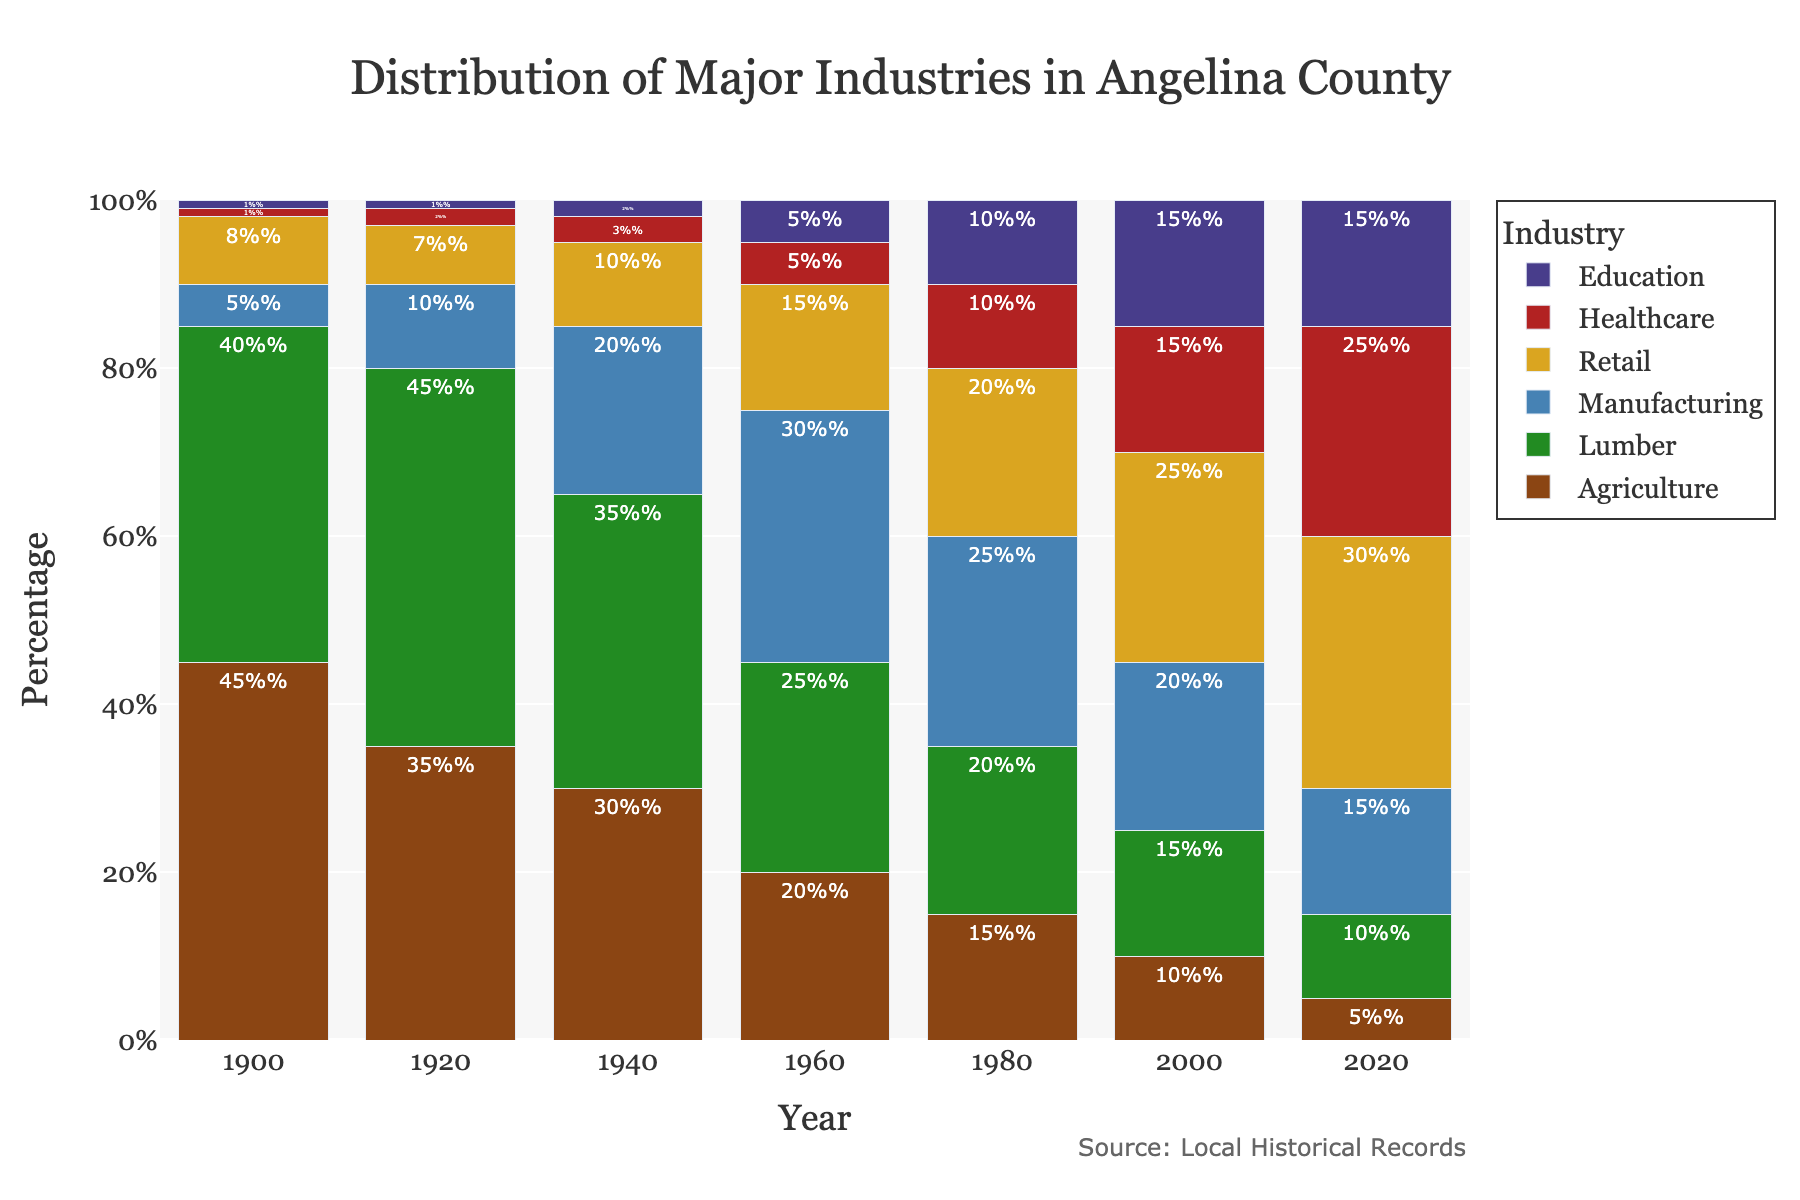What major industry in Angelina County had the highest percentage in 1900? In 1900, the bar for Agriculture is the tallest among all industries, indicating the highest percentage.
Answer: Agriculture How did the percentage of the Healthcare industry change from 1940 to 2020? In 1940, the Healthcare industry has 3%, and by 2020, it has increased to 25%, showing a significant growth.
Answer: Increased by 22% Which two industries had equal percentages in 2020? In 2020, the bars for Education and Manufacturing are both at 15%.
Answer: Education and Manufacturing In which decade did Retail first surpass Manufacturing in percentage? Retail first surpasses Manufacturing in 2000, as indicated by the taller bar for Retail compared to Manufacturing.
Answer: 2000 What is the sum of the percentages of Lumber and Retail industries in 1980? In 1980, Lumber stands at 20% and Retail at 20%; hence, the sum is 20% + 20% = 40%.
Answer: 40% Between 1900 and 2020, which industry shows a consistent decline in percentage? The Agriculture industry shows a consistent decline from 45% in 1900 down to 5% in 2020.
Answer: Agriculture Which industry experienced the largest increase in its percentage from 1900 to 2020? The Healthcare industry increased from 1% in 1900 to 25% in 2020, marking the largest rise among all industries.
Answer: Healthcare How did the percentage of the Lumber industry change between 1960 and 1980? Lumber decreased from 25% in 1960 to 20% in 1980.
Answer: Decreased by 5% Which two industries had equal percentages in 1960, and what were they? In 1960, the bars for Education and Healthcare are both at 5%.
Answer: Education and Healthcare, 5% What is the difference between the highest and lowest industry percentages in 1920? In 1920, the highest industry percentage is 45% (Lumber) and the lowest is 1% (Education), giving a difference of 44%.
Answer: 44% 